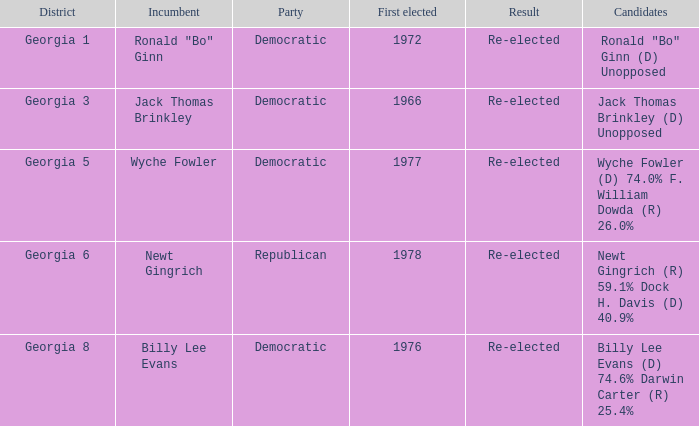How many candidates were first elected in 1972? 1.0. 